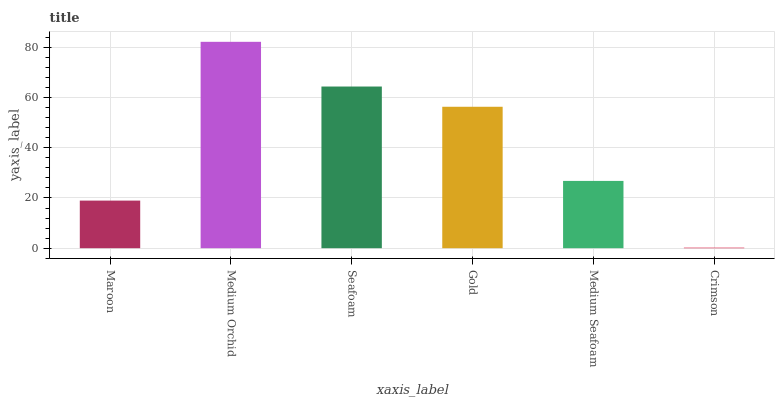Is Crimson the minimum?
Answer yes or no. Yes. Is Medium Orchid the maximum?
Answer yes or no. Yes. Is Seafoam the minimum?
Answer yes or no. No. Is Seafoam the maximum?
Answer yes or no. No. Is Medium Orchid greater than Seafoam?
Answer yes or no. Yes. Is Seafoam less than Medium Orchid?
Answer yes or no. Yes. Is Seafoam greater than Medium Orchid?
Answer yes or no. No. Is Medium Orchid less than Seafoam?
Answer yes or no. No. Is Gold the high median?
Answer yes or no. Yes. Is Medium Seafoam the low median?
Answer yes or no. Yes. Is Medium Orchid the high median?
Answer yes or no. No. Is Seafoam the low median?
Answer yes or no. No. 